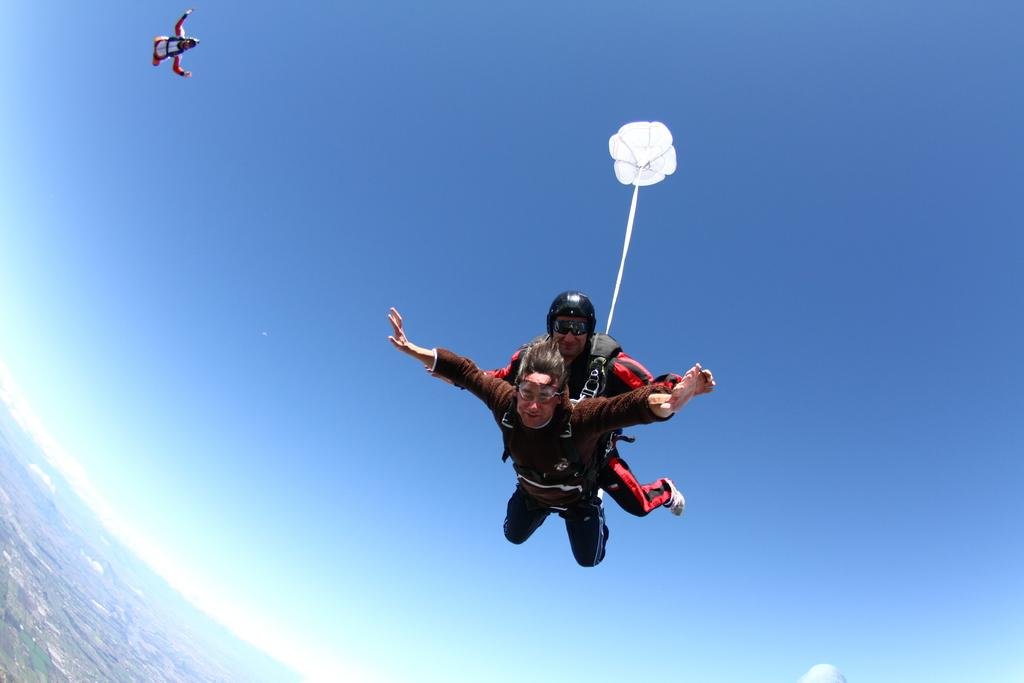What are the three persons in the image doing? The three persons in the image are skydiving. What can be seen in the left corner of the image? Clouds are visible in the left corner of the image. How is the image taken? The image provides a top view from the sky to the earth. What type of cord is being used by the skydivers to attach themselves to the land? There is no cord visible in the image, and the skydivers are not attached to the land. Can you see a cork floating in the sky in the image? There is no cork present in the image. 